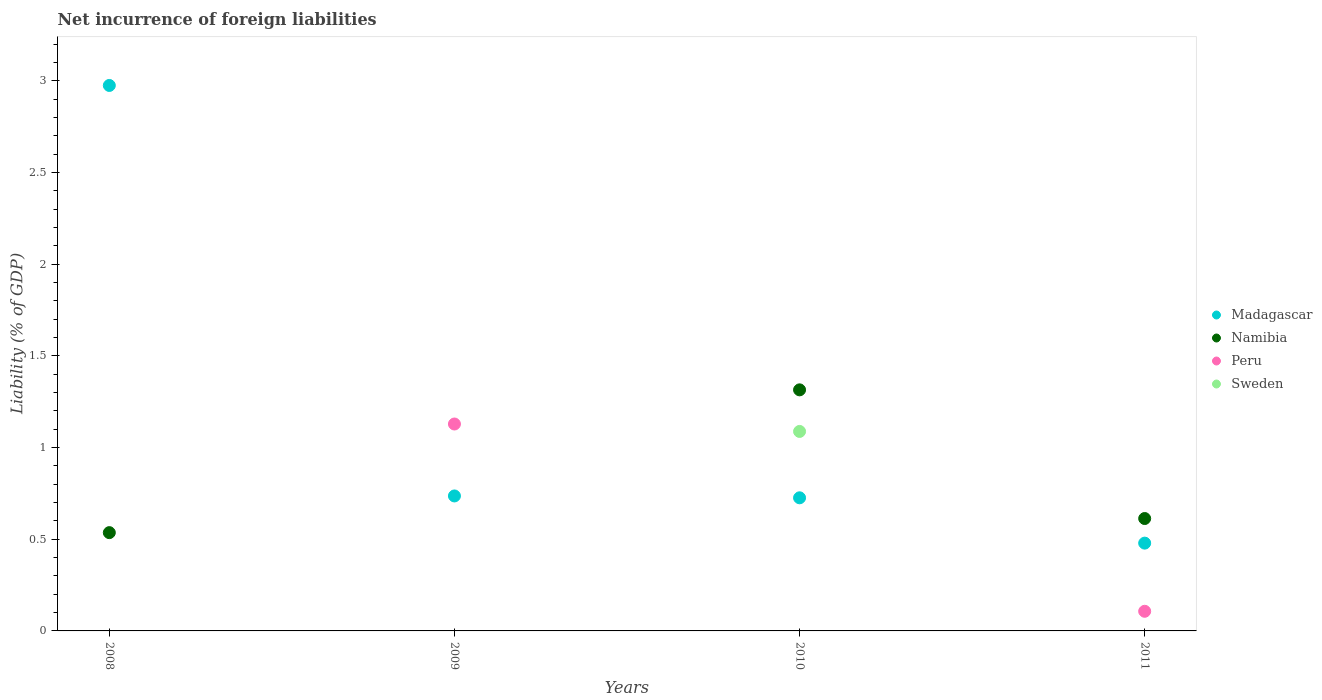Is the number of dotlines equal to the number of legend labels?
Your answer should be compact. No. What is the net incurrence of foreign liabilities in Sweden in 2011?
Provide a succinct answer. 0. Across all years, what is the maximum net incurrence of foreign liabilities in Peru?
Your response must be concise. 1.13. Across all years, what is the minimum net incurrence of foreign liabilities in Namibia?
Ensure brevity in your answer.  0. What is the total net incurrence of foreign liabilities in Madagascar in the graph?
Keep it short and to the point. 4.91. What is the difference between the net incurrence of foreign liabilities in Namibia in 2008 and that in 2011?
Offer a terse response. -0.08. What is the difference between the net incurrence of foreign liabilities in Madagascar in 2010 and the net incurrence of foreign liabilities in Peru in 2008?
Offer a very short reply. 0.73. What is the average net incurrence of foreign liabilities in Sweden per year?
Your response must be concise. 0.27. In the year 2010, what is the difference between the net incurrence of foreign liabilities in Sweden and net incurrence of foreign liabilities in Madagascar?
Your answer should be very brief. 0.36. What is the ratio of the net incurrence of foreign liabilities in Madagascar in 2008 to that in 2011?
Give a very brief answer. 6.21. What is the difference between the highest and the second highest net incurrence of foreign liabilities in Namibia?
Give a very brief answer. 0.7. What is the difference between the highest and the lowest net incurrence of foreign liabilities in Namibia?
Keep it short and to the point. 1.31. Is the sum of the net incurrence of foreign liabilities in Namibia in 2008 and 2011 greater than the maximum net incurrence of foreign liabilities in Madagascar across all years?
Provide a succinct answer. No. Is it the case that in every year, the sum of the net incurrence of foreign liabilities in Sweden and net incurrence of foreign liabilities in Madagascar  is greater than the sum of net incurrence of foreign liabilities in Peru and net incurrence of foreign liabilities in Namibia?
Your answer should be very brief. No. Does the net incurrence of foreign liabilities in Madagascar monotonically increase over the years?
Offer a very short reply. No. Is the net incurrence of foreign liabilities in Madagascar strictly greater than the net incurrence of foreign liabilities in Namibia over the years?
Your answer should be compact. No. Is the net incurrence of foreign liabilities in Sweden strictly less than the net incurrence of foreign liabilities in Namibia over the years?
Provide a short and direct response. Yes. How many dotlines are there?
Provide a succinct answer. 4. What is the difference between two consecutive major ticks on the Y-axis?
Your answer should be very brief. 0.5. What is the title of the graph?
Offer a terse response. Net incurrence of foreign liabilities. Does "Upper middle income" appear as one of the legend labels in the graph?
Provide a succinct answer. No. What is the label or title of the X-axis?
Provide a succinct answer. Years. What is the label or title of the Y-axis?
Make the answer very short. Liability (% of GDP). What is the Liability (% of GDP) of Madagascar in 2008?
Give a very brief answer. 2.97. What is the Liability (% of GDP) in Namibia in 2008?
Your answer should be compact. 0.54. What is the Liability (% of GDP) in Madagascar in 2009?
Keep it short and to the point. 0.74. What is the Liability (% of GDP) of Namibia in 2009?
Your answer should be very brief. 0. What is the Liability (% of GDP) of Peru in 2009?
Your answer should be very brief. 1.13. What is the Liability (% of GDP) in Madagascar in 2010?
Your answer should be very brief. 0.73. What is the Liability (% of GDP) in Namibia in 2010?
Make the answer very short. 1.31. What is the Liability (% of GDP) of Peru in 2010?
Offer a very short reply. 0. What is the Liability (% of GDP) in Sweden in 2010?
Your response must be concise. 1.09. What is the Liability (% of GDP) of Madagascar in 2011?
Your answer should be compact. 0.48. What is the Liability (% of GDP) in Namibia in 2011?
Your answer should be compact. 0.61. What is the Liability (% of GDP) of Peru in 2011?
Your answer should be very brief. 0.11. What is the Liability (% of GDP) of Sweden in 2011?
Make the answer very short. 0. Across all years, what is the maximum Liability (% of GDP) in Madagascar?
Your answer should be compact. 2.97. Across all years, what is the maximum Liability (% of GDP) in Namibia?
Provide a succinct answer. 1.31. Across all years, what is the maximum Liability (% of GDP) of Peru?
Give a very brief answer. 1.13. Across all years, what is the maximum Liability (% of GDP) in Sweden?
Your response must be concise. 1.09. Across all years, what is the minimum Liability (% of GDP) of Madagascar?
Offer a very short reply. 0.48. Across all years, what is the minimum Liability (% of GDP) of Namibia?
Keep it short and to the point. 0. Across all years, what is the minimum Liability (% of GDP) in Peru?
Provide a short and direct response. 0. What is the total Liability (% of GDP) of Madagascar in the graph?
Offer a terse response. 4.91. What is the total Liability (% of GDP) of Namibia in the graph?
Give a very brief answer. 2.46. What is the total Liability (% of GDP) in Peru in the graph?
Give a very brief answer. 1.24. What is the total Liability (% of GDP) of Sweden in the graph?
Make the answer very short. 1.09. What is the difference between the Liability (% of GDP) of Madagascar in 2008 and that in 2009?
Your response must be concise. 2.24. What is the difference between the Liability (% of GDP) of Madagascar in 2008 and that in 2010?
Provide a succinct answer. 2.25. What is the difference between the Liability (% of GDP) of Namibia in 2008 and that in 2010?
Offer a terse response. -0.78. What is the difference between the Liability (% of GDP) of Madagascar in 2008 and that in 2011?
Your answer should be very brief. 2.5. What is the difference between the Liability (% of GDP) in Namibia in 2008 and that in 2011?
Keep it short and to the point. -0.08. What is the difference between the Liability (% of GDP) of Madagascar in 2009 and that in 2010?
Offer a terse response. 0.01. What is the difference between the Liability (% of GDP) in Madagascar in 2009 and that in 2011?
Give a very brief answer. 0.26. What is the difference between the Liability (% of GDP) in Peru in 2009 and that in 2011?
Offer a terse response. 1.02. What is the difference between the Liability (% of GDP) of Madagascar in 2010 and that in 2011?
Your answer should be compact. 0.25. What is the difference between the Liability (% of GDP) in Namibia in 2010 and that in 2011?
Your answer should be compact. 0.7. What is the difference between the Liability (% of GDP) of Madagascar in 2008 and the Liability (% of GDP) of Peru in 2009?
Offer a terse response. 1.85. What is the difference between the Liability (% of GDP) in Namibia in 2008 and the Liability (% of GDP) in Peru in 2009?
Your response must be concise. -0.59. What is the difference between the Liability (% of GDP) in Madagascar in 2008 and the Liability (% of GDP) in Namibia in 2010?
Your answer should be compact. 1.66. What is the difference between the Liability (% of GDP) in Madagascar in 2008 and the Liability (% of GDP) in Sweden in 2010?
Offer a very short reply. 1.89. What is the difference between the Liability (% of GDP) in Namibia in 2008 and the Liability (% of GDP) in Sweden in 2010?
Provide a succinct answer. -0.55. What is the difference between the Liability (% of GDP) in Madagascar in 2008 and the Liability (% of GDP) in Namibia in 2011?
Provide a short and direct response. 2.36. What is the difference between the Liability (% of GDP) in Madagascar in 2008 and the Liability (% of GDP) in Peru in 2011?
Keep it short and to the point. 2.87. What is the difference between the Liability (% of GDP) of Namibia in 2008 and the Liability (% of GDP) of Peru in 2011?
Your response must be concise. 0.43. What is the difference between the Liability (% of GDP) of Madagascar in 2009 and the Liability (% of GDP) of Namibia in 2010?
Your answer should be very brief. -0.58. What is the difference between the Liability (% of GDP) in Madagascar in 2009 and the Liability (% of GDP) in Sweden in 2010?
Provide a succinct answer. -0.35. What is the difference between the Liability (% of GDP) of Peru in 2009 and the Liability (% of GDP) of Sweden in 2010?
Your response must be concise. 0.04. What is the difference between the Liability (% of GDP) in Madagascar in 2009 and the Liability (% of GDP) in Namibia in 2011?
Your answer should be very brief. 0.12. What is the difference between the Liability (% of GDP) of Madagascar in 2009 and the Liability (% of GDP) of Peru in 2011?
Your response must be concise. 0.63. What is the difference between the Liability (% of GDP) in Madagascar in 2010 and the Liability (% of GDP) in Namibia in 2011?
Your answer should be compact. 0.11. What is the difference between the Liability (% of GDP) of Madagascar in 2010 and the Liability (% of GDP) of Peru in 2011?
Provide a short and direct response. 0.62. What is the difference between the Liability (% of GDP) in Namibia in 2010 and the Liability (% of GDP) in Peru in 2011?
Your response must be concise. 1.21. What is the average Liability (% of GDP) in Madagascar per year?
Make the answer very short. 1.23. What is the average Liability (% of GDP) of Namibia per year?
Ensure brevity in your answer.  0.62. What is the average Liability (% of GDP) in Peru per year?
Provide a succinct answer. 0.31. What is the average Liability (% of GDP) in Sweden per year?
Ensure brevity in your answer.  0.27. In the year 2008, what is the difference between the Liability (% of GDP) of Madagascar and Liability (% of GDP) of Namibia?
Keep it short and to the point. 2.44. In the year 2009, what is the difference between the Liability (% of GDP) of Madagascar and Liability (% of GDP) of Peru?
Make the answer very short. -0.39. In the year 2010, what is the difference between the Liability (% of GDP) in Madagascar and Liability (% of GDP) in Namibia?
Offer a terse response. -0.59. In the year 2010, what is the difference between the Liability (% of GDP) in Madagascar and Liability (% of GDP) in Sweden?
Provide a short and direct response. -0.36. In the year 2010, what is the difference between the Liability (% of GDP) of Namibia and Liability (% of GDP) of Sweden?
Provide a succinct answer. 0.23. In the year 2011, what is the difference between the Liability (% of GDP) of Madagascar and Liability (% of GDP) of Namibia?
Give a very brief answer. -0.13. In the year 2011, what is the difference between the Liability (% of GDP) in Madagascar and Liability (% of GDP) in Peru?
Give a very brief answer. 0.37. In the year 2011, what is the difference between the Liability (% of GDP) of Namibia and Liability (% of GDP) of Peru?
Give a very brief answer. 0.51. What is the ratio of the Liability (% of GDP) of Madagascar in 2008 to that in 2009?
Keep it short and to the point. 4.04. What is the ratio of the Liability (% of GDP) of Madagascar in 2008 to that in 2010?
Your answer should be very brief. 4.1. What is the ratio of the Liability (% of GDP) of Namibia in 2008 to that in 2010?
Provide a short and direct response. 0.41. What is the ratio of the Liability (% of GDP) of Madagascar in 2008 to that in 2011?
Ensure brevity in your answer.  6.21. What is the ratio of the Liability (% of GDP) of Namibia in 2008 to that in 2011?
Offer a very short reply. 0.87. What is the ratio of the Liability (% of GDP) of Madagascar in 2009 to that in 2011?
Make the answer very short. 1.54. What is the ratio of the Liability (% of GDP) of Peru in 2009 to that in 2011?
Your answer should be compact. 10.54. What is the ratio of the Liability (% of GDP) in Madagascar in 2010 to that in 2011?
Keep it short and to the point. 1.52. What is the ratio of the Liability (% of GDP) in Namibia in 2010 to that in 2011?
Your answer should be very brief. 2.14. What is the difference between the highest and the second highest Liability (% of GDP) in Madagascar?
Give a very brief answer. 2.24. What is the difference between the highest and the second highest Liability (% of GDP) in Namibia?
Provide a succinct answer. 0.7. What is the difference between the highest and the lowest Liability (% of GDP) of Madagascar?
Provide a short and direct response. 2.5. What is the difference between the highest and the lowest Liability (% of GDP) in Namibia?
Your answer should be very brief. 1.31. What is the difference between the highest and the lowest Liability (% of GDP) in Peru?
Make the answer very short. 1.13. What is the difference between the highest and the lowest Liability (% of GDP) in Sweden?
Offer a very short reply. 1.09. 